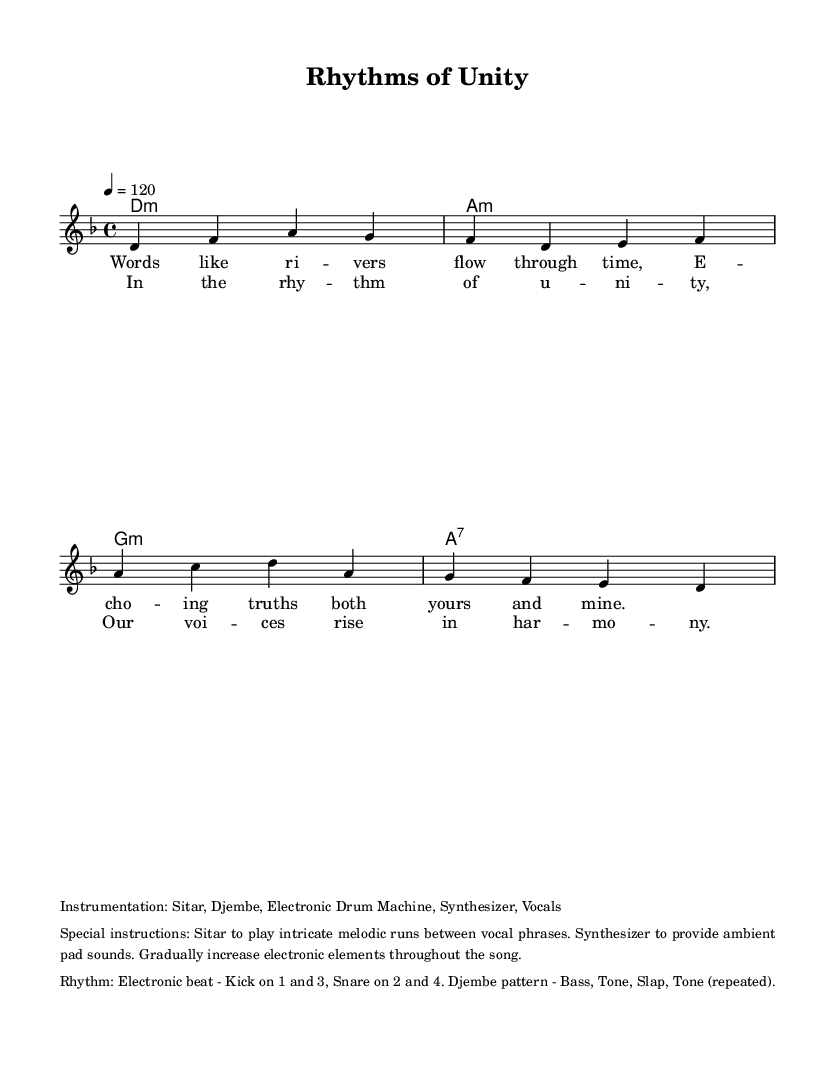What is the key signature of this music? The key signature is D minor, which contains one flat (B♭). This is apparent from the global setup where the key is defined.
Answer: D minor What is the time signature of the piece? The time signature is 4/4, which indicates that there are four beats in each measure and a quarter note receives one beat. This is established in the global section of the code.
Answer: 4/4 What is the tempo marking for this composition? The tempo marking indicates the speed of the piece, given as "4 = 120," meaning there are 120 quarter note beats per minute. This is also located in the global definition.
Answer: 120 How many measures are in the chorus section? The chorus consists of eight measures, as it follows the format of the melody and harmonies throughout the structured sections in the sheet music. By counting the melodic phrases and their repetitions, you can conclude this.
Answer: 8 What traditional instrument is specified in the instrumentation? The specified traditional instrument is the Sitar. It is listed among other instruments in the instrumentation markup, indicating its integral role in the composition.
Answer: Sitar What rhythmic pattern is indicated for the Djembe? The rhythmic pattern for the Djembe is described as "Bass, Tone, Slap, Tone (repeated)," outlining the specific sounds to be played in each sequence. This is detailed in the rhythm markup section at the end of the code.
Answer: Bass, Tone, Slap, Tone What is the primary theme of the lyrics? The theme of the lyrics revolves around unity and shared experiences, reflected in the lines and their poetic structure that stresses connection and harmony between individuals. This is interpreted by analyzing both verses and chorus together.
Answer: Unity 